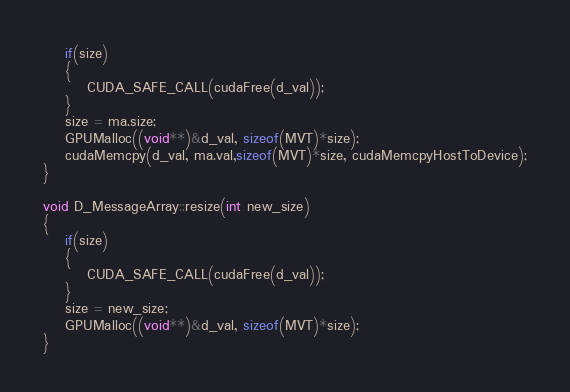Convert code to text. <code><loc_0><loc_0><loc_500><loc_500><_Cuda_>	if(size)
	{
		CUDA_SAFE_CALL(cudaFree(d_val));
	}
	size = ma.size;
	GPUMalloc((void**)&d_val, sizeof(MVT)*size);
	cudaMemcpy(d_val, ma.val,sizeof(MVT)*size, cudaMemcpyHostToDevice);
}

void D_MessageArray::resize(int new_size)
{
	if(size)
	{
		CUDA_SAFE_CALL(cudaFree(d_val));
	}
	size = new_size;
	GPUMalloc((void**)&d_val, sizeof(MVT)*size);
}

</code> 